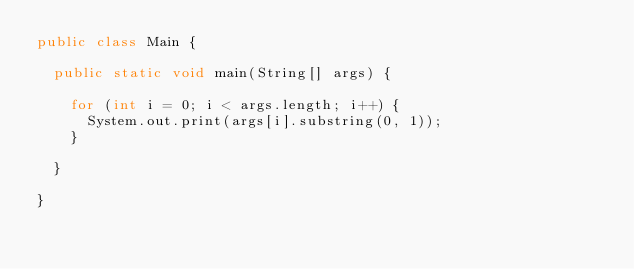<code> <loc_0><loc_0><loc_500><loc_500><_Java_>public class Main {

	public static void main(String[] args) {

		for (int i = 0; i < args.length; i++) {
			System.out.print(args[i].substring(0, 1));
		}

	}

}</code> 